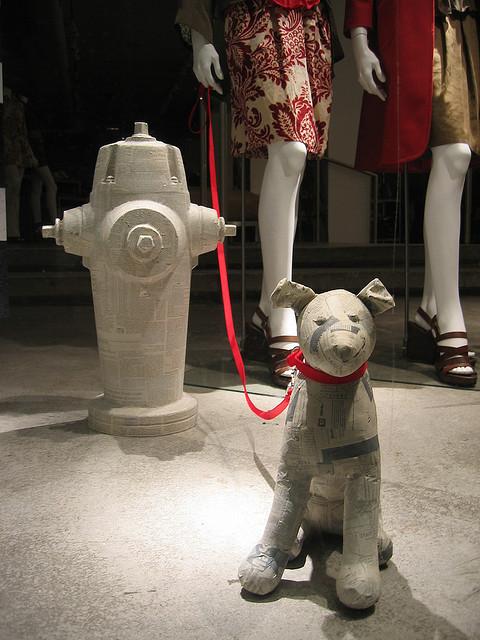Is this dog real or a toy?
Answer briefly. Toy. Are all of them yellow fire hydrants?
Keep it brief. No. What color is the dog's leash?
Be succinct. Red. Which fire hydrant is most common?
Short answer required. Red. Is the fire hydrant functional?
Keep it brief. No. 